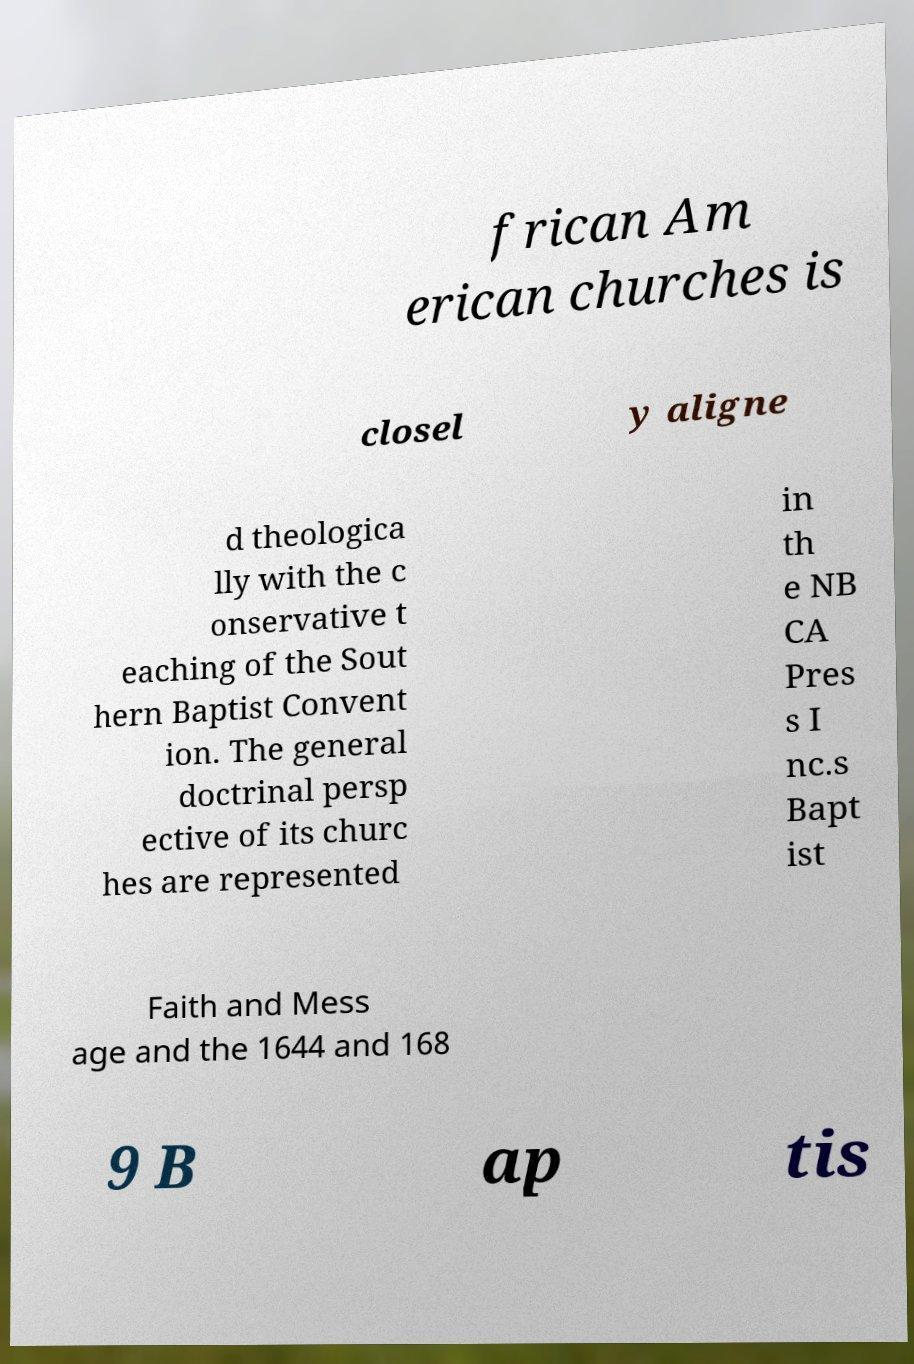I need the written content from this picture converted into text. Can you do that? frican Am erican churches is closel y aligne d theologica lly with the c onservative t eaching of the Sout hern Baptist Convent ion. The general doctrinal persp ective of its churc hes are represented in th e NB CA Pres s I nc.s Bapt ist Faith and Mess age and the 1644 and 168 9 B ap tis 